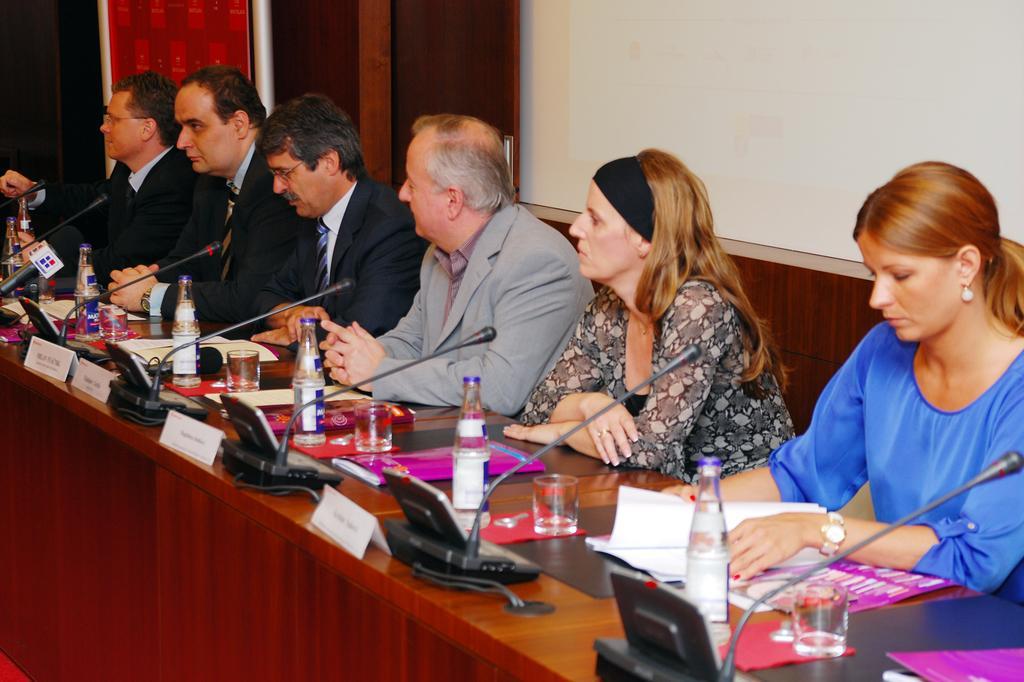Could you give a brief overview of what you see in this image? In this picture there is a woman who is wearing blue t-shirt and watch, beside her we can see another woman who is wearing headband and black dress. She is sitting on the chair. Beside her we can see a man who is wearing grey blazer. On the right there is another man who is wearing spectacle and suit. Beside him we can see another man who is also wearing suit and sitting near to the table. On the table we can see water bottles, water glasses, nameplate, papers, mat, tissue papers, cables and other objects. In the top right there is a projector screen. At the top there is a door. 